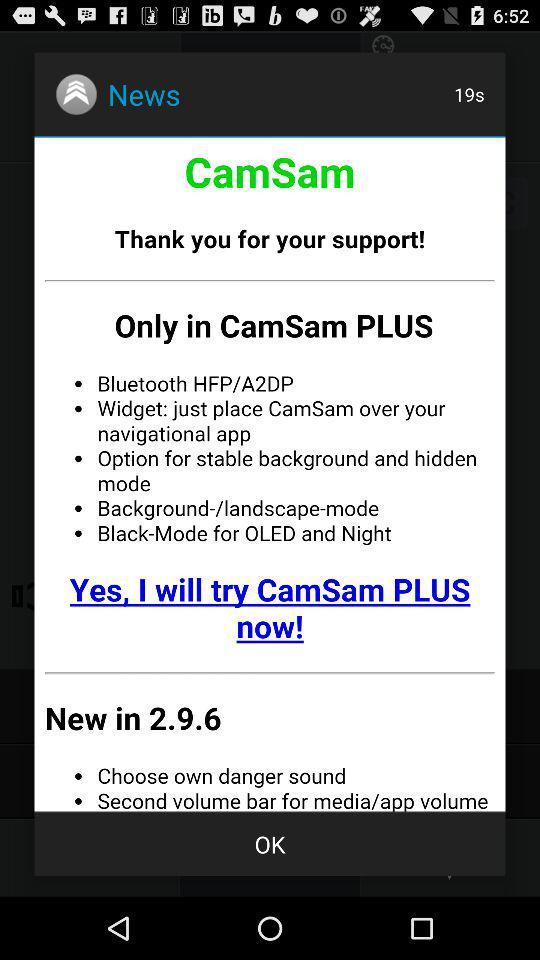What is new in the application version 2.9.6? New in application version 2.9.6 are "Choose own danger sound" and "Second volume bar for media/ app volume". 